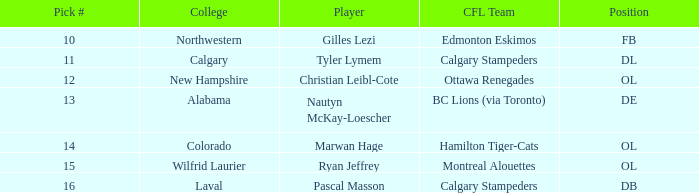In the 2004 cfl draft, who was the player that attended wilfrid laurier? Ryan Jeffrey. 